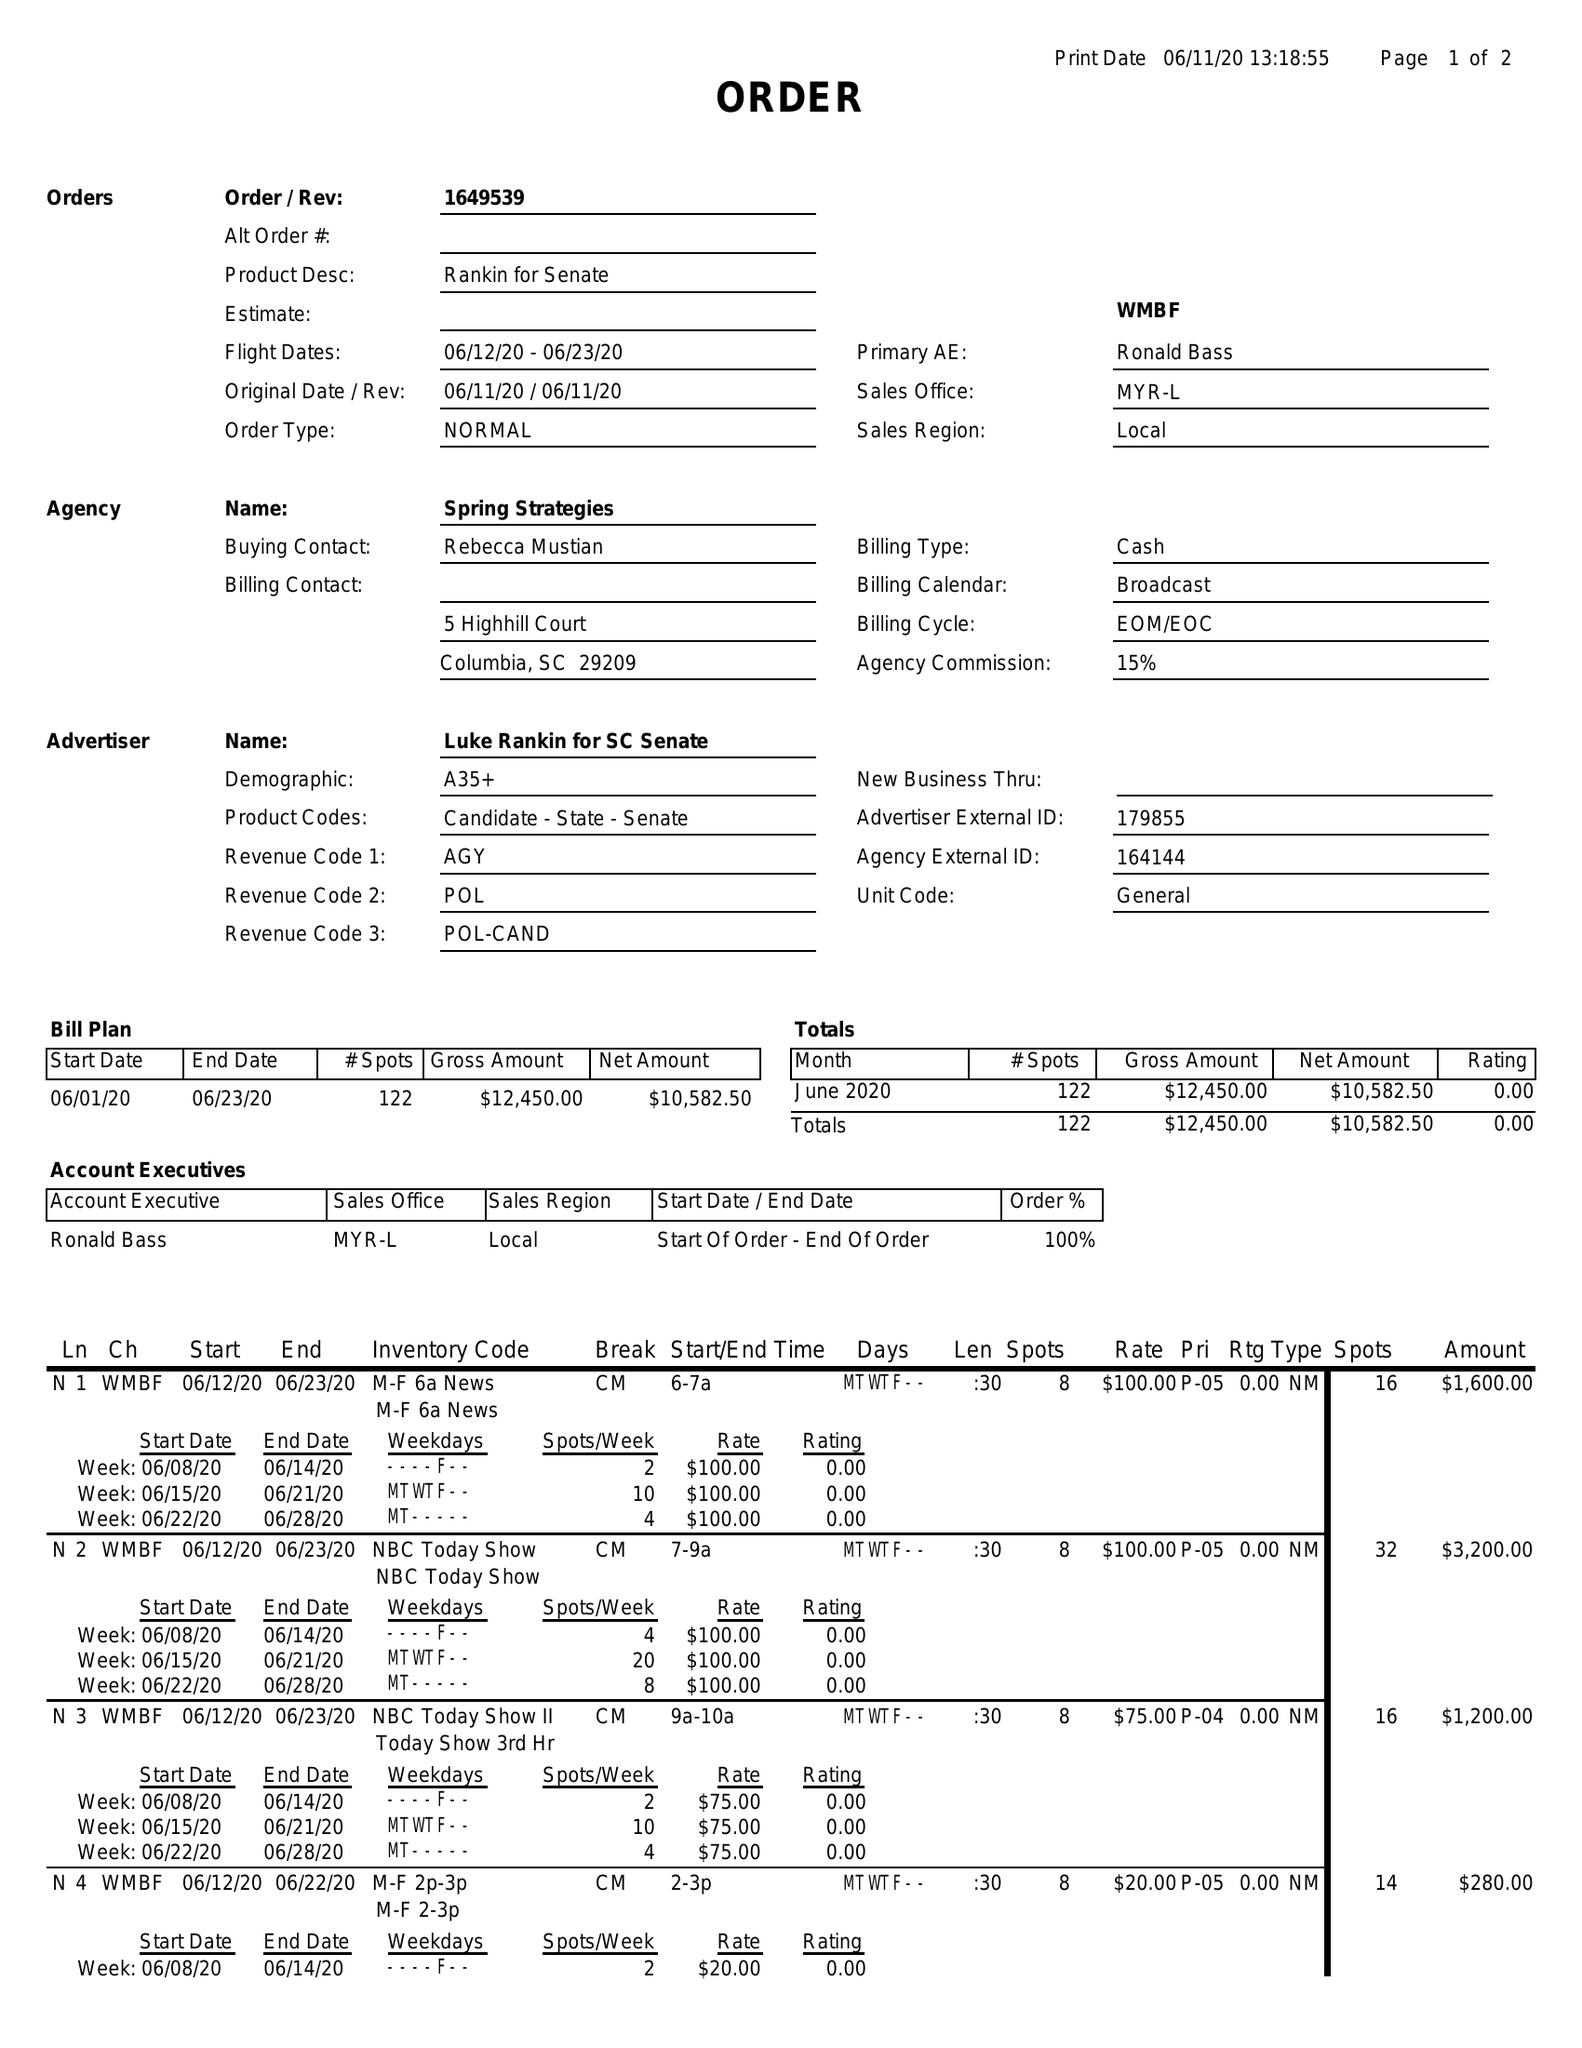What is the value for the contract_num?
Answer the question using a single word or phrase. 1649539 